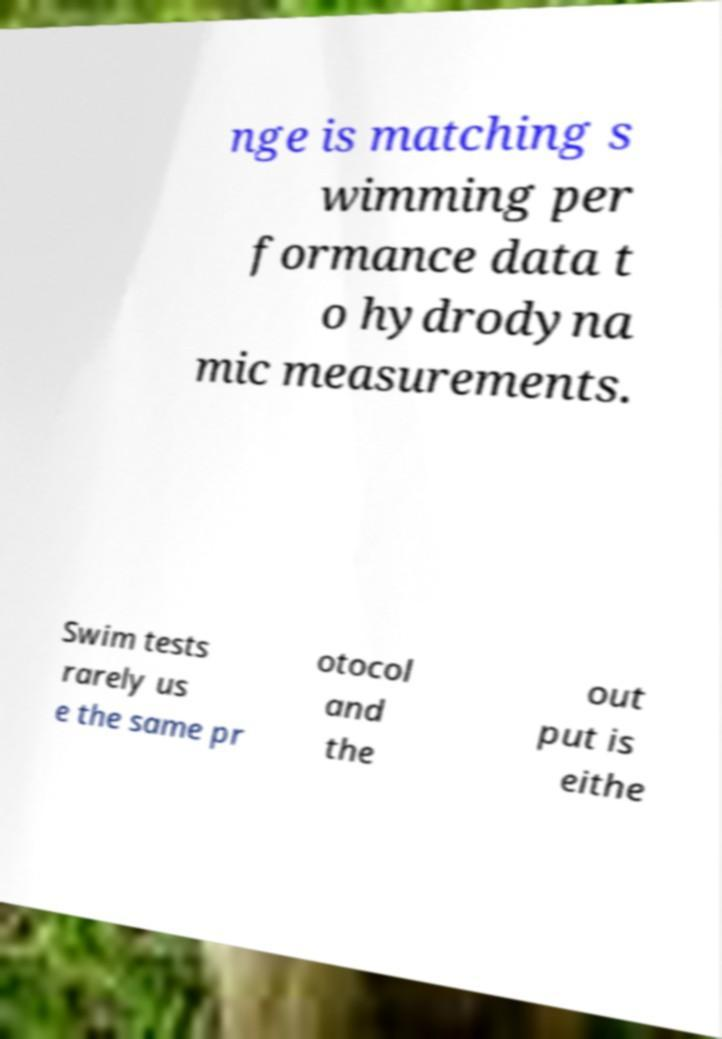Can you accurately transcribe the text from the provided image for me? nge is matching s wimming per formance data t o hydrodyna mic measurements. Swim tests rarely us e the same pr otocol and the out put is eithe 